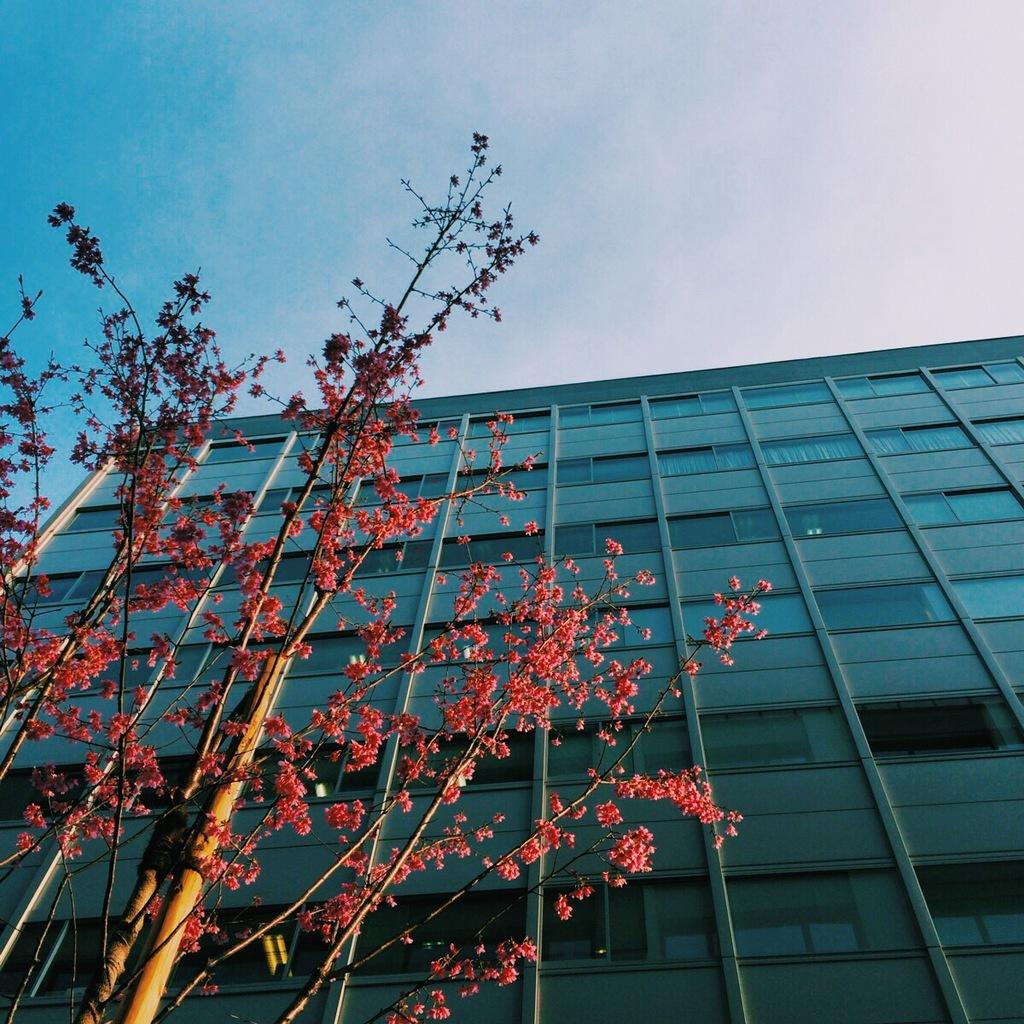What type of tree is on the left side of the image? There is a tree with flowers on the left side of the image. What is located near the tree? There is a pole near the tree. What can be seen in the background of the image? There is a building with windows in the background of the image. What is the color of the sky in the image? The sky is blue with clouds in the image. What type of ball is being used for division in the image? There is no ball or division activity present in the image. What emotion is being displayed by the tree in the image? Trees do not display emotions, so it is not possible to determine the emotion being displayed by the tree in the image. 